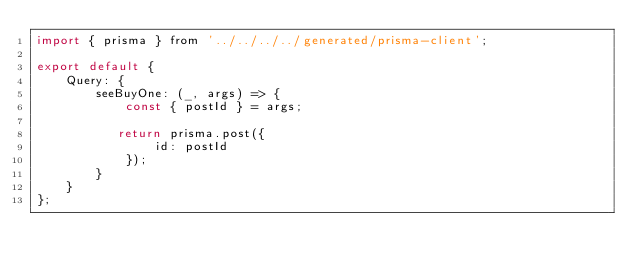<code> <loc_0><loc_0><loc_500><loc_500><_JavaScript_>import { prisma } from '../../../../generated/prisma-client';

export default {
    Query: {
        seeBuyOne: (_, args) => {
            const { postId } = args;

           return prisma.post({
                id: postId    
            });
        }
    }
};</code> 